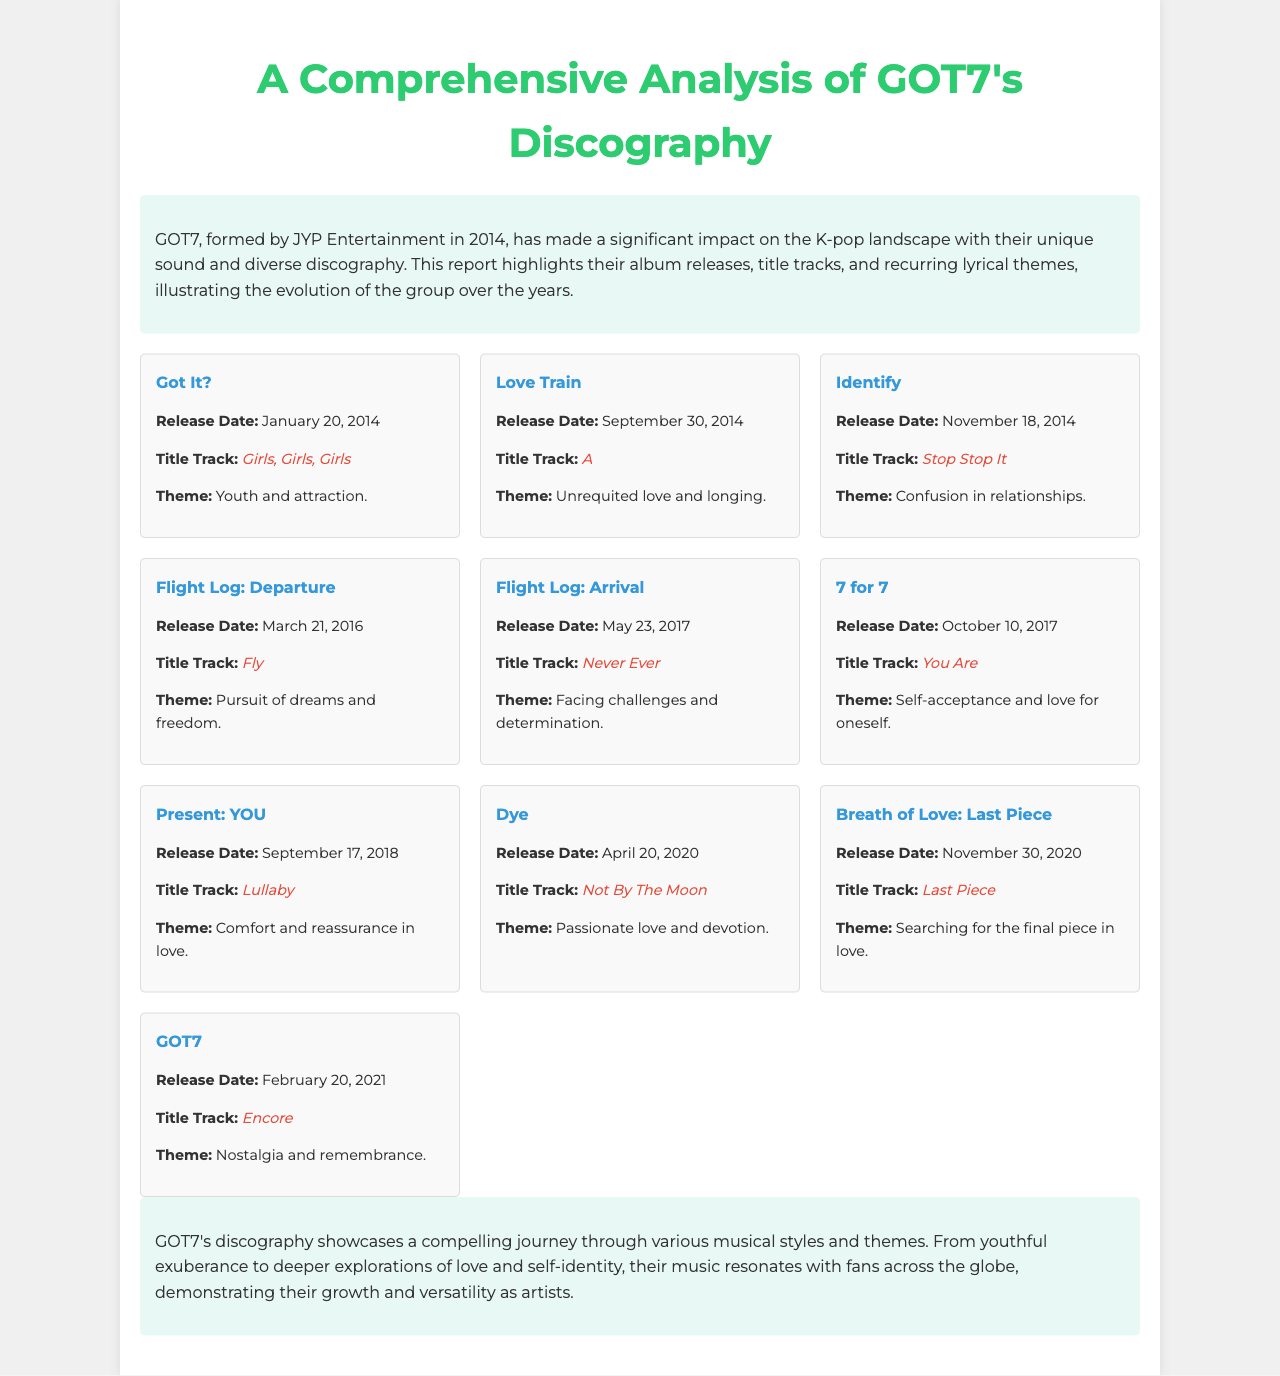What is the title track of the album "Love Train"? The title track of the album "Love Train" is mentioned in the album information section.
Answer: A When was the album "Dye" released? The release date of the album "Dye" is specified in the album information provided.
Answer: April 20, 2020 What theme is associated with the album "Flight Log: Departure"? The theme associated with the album "Flight Log: Departure" is listed in the album summary.
Answer: Pursuit of dreams and freedom Which album features the title track "Lullaby"? The album featuring the title track "Lullaby" is detailed in the document's album list.
Answer: Present: YOU What is the common theme across GOT7's discography? The conclusion summarizes the overarching themes present in GOT7's music as analyzed throughout the report.
Answer: Growth and versatility 